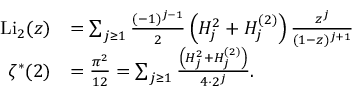Convert formula to latex. <formula><loc_0><loc_0><loc_500><loc_500>{ \begin{array} { r l } { { L i } _ { 2 } ( z ) } & { = \sum _ { j \geq 1 } { \frac { ( - 1 ) ^ { j - 1 } } { 2 } } \left ( H _ { j } ^ { 2 } + H _ { j } ^ { ( 2 ) } \right ) { \frac { z ^ { j } } { ( 1 - z ) ^ { j + 1 } } } } \\ { \zeta ^ { \ast } ( 2 ) } & { = { \frac { \pi ^ { 2 } } { 1 2 } } = \sum _ { j \geq 1 } { \frac { \left ( H _ { j } ^ { 2 } + H _ { j } ^ { ( 2 ) } \right ) } { 4 \cdot 2 ^ { j } } } . } \end{array} }</formula> 